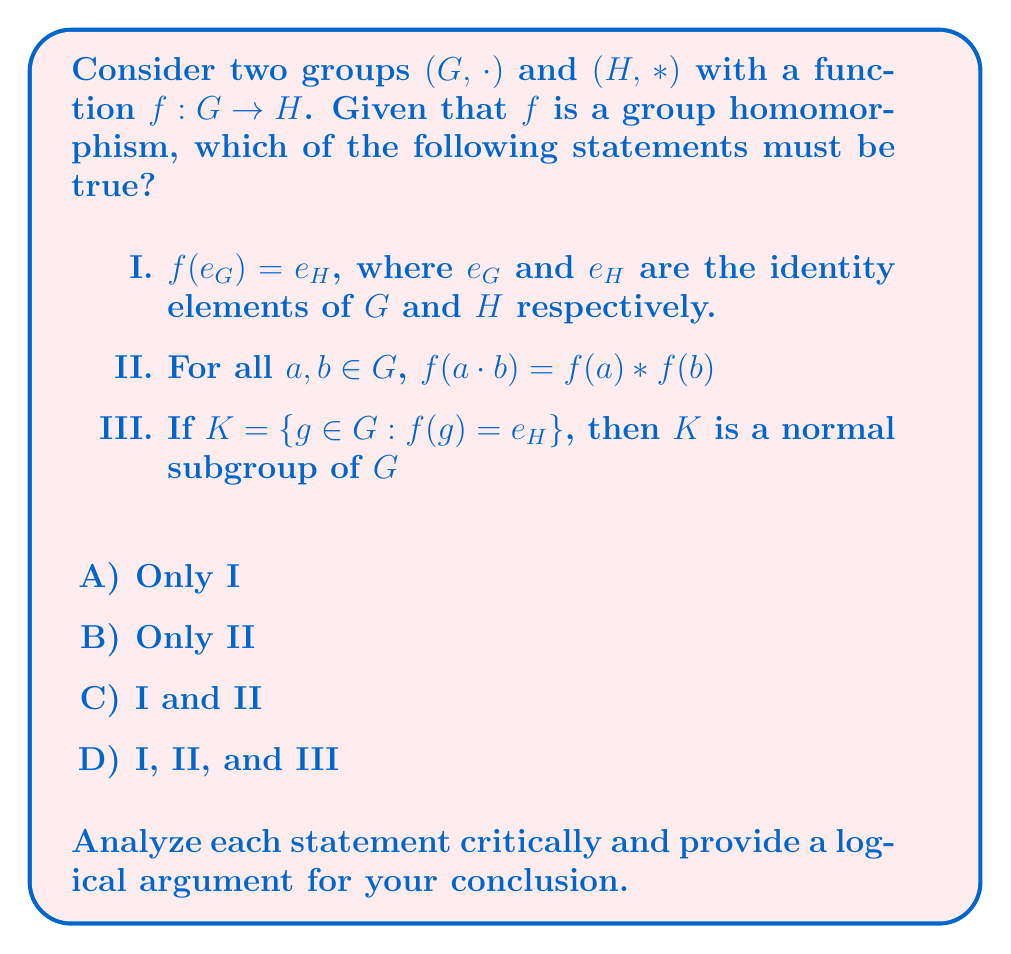Can you answer this question? Let's examine each statement critically:

1. Statement I: $f(e_G) = e_H$

To prove this, let's consider $f(e_G)$:
$$f(e_G \cdot e_G) = f(e_G) * f(e_G)$$

This is true because $f$ is a homomorphism. Now, since $e_G \cdot e_G = e_G$, we have:
$$f(e_G) = f(e_G) * f(e_G)$$

In group $H$, this equation is only satisfied if $f(e_G) = e_H$. Therefore, Statement I is true.

2. Statement II: For all $a, b \in G$, $f(a \cdot b) = f(a) * f(b)$

This is the definition of a group homomorphism. Therefore, Statement II is true by definition.

3. Statement III: If $K = \{g \in G : f(g) = e_H\}$, then $K$ is a normal subgroup of $G$

To prove this, we need to show that $K$ is a subgroup and that it's normal.

a) $K$ is a subgroup:
   - $e_G \in K$ because $f(e_G) = e_H$ (from Statement I)
   - If $a, b \in K$, then $f(a \cdot b) = f(a) * f(b) = e_H * e_H = e_H$, so $a \cdot b \in K$
   - If $a \in K$, then $f(a^{-1}) * f(a) = f(a^{-1} \cdot a) = f(e_G) = e_H$, so $f(a^{-1}) = e_H$, and $a^{-1} \in K$

b) $K$ is normal:
   For any $g \in G$ and $k \in K$, we need to show that $gkg^{-1} \in K$:
   $$f(gkg^{-1}) = f(g) * f(k) * f(g^{-1}) = f(g) * e_H * f(g)^{-1} = e_H$$

Therefore, $gkg^{-1} \in K$, so $K$ is normal.

Thus, Statement III is also true.

Since all three statements are true, the correct answer is D) I, II, and III.
Answer: D) I, II, and III 